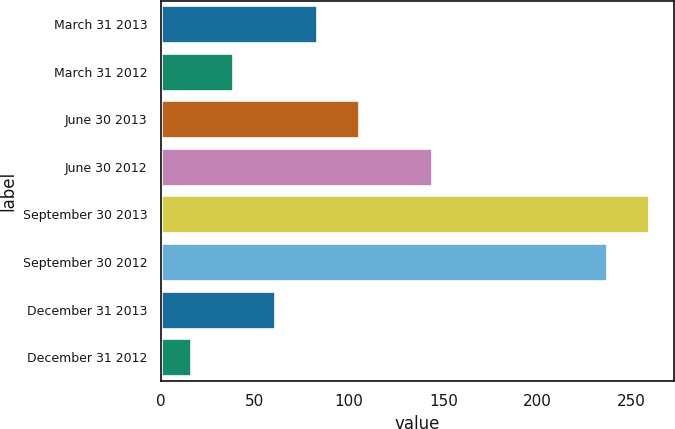Convert chart. <chart><loc_0><loc_0><loc_500><loc_500><bar_chart><fcel>March 31 2013<fcel>March 31 2012<fcel>June 30 2013<fcel>June 30 2012<fcel>September 30 2013<fcel>September 30 2012<fcel>December 31 2013<fcel>December 31 2012<nl><fcel>82.9<fcel>38.3<fcel>105.2<fcel>144<fcel>259.3<fcel>237<fcel>60.6<fcel>16<nl></chart> 